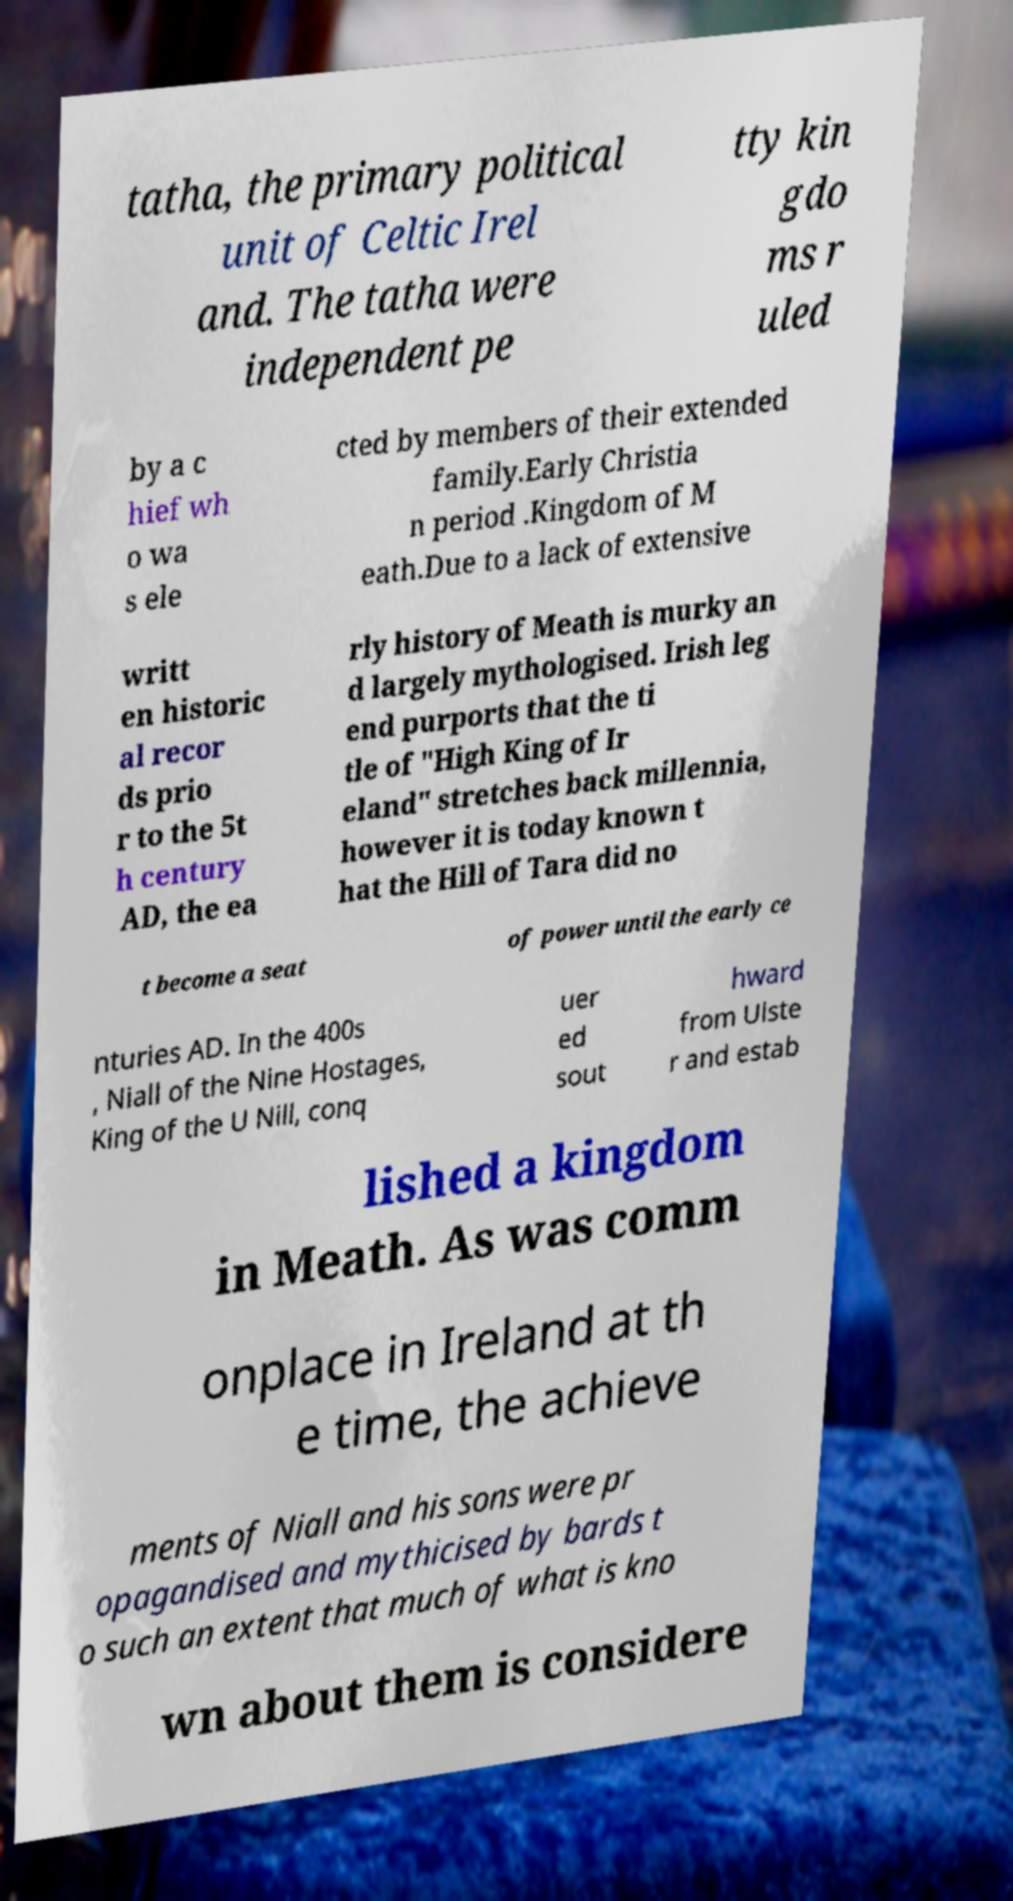There's text embedded in this image that I need extracted. Can you transcribe it verbatim? tatha, the primary political unit of Celtic Irel and. The tatha were independent pe tty kin gdo ms r uled by a c hief wh o wa s ele cted by members of their extended family.Early Christia n period .Kingdom of M eath.Due to a lack of extensive writt en historic al recor ds prio r to the 5t h century AD, the ea rly history of Meath is murky an d largely mythologised. Irish leg end purports that the ti tle of "High King of Ir eland" stretches back millennia, however it is today known t hat the Hill of Tara did no t become a seat of power until the early ce nturies AD. In the 400s , Niall of the Nine Hostages, King of the U Nill, conq uer ed sout hward from Ulste r and estab lished a kingdom in Meath. As was comm onplace in Ireland at th e time, the achieve ments of Niall and his sons were pr opagandised and mythicised by bards t o such an extent that much of what is kno wn about them is considere 